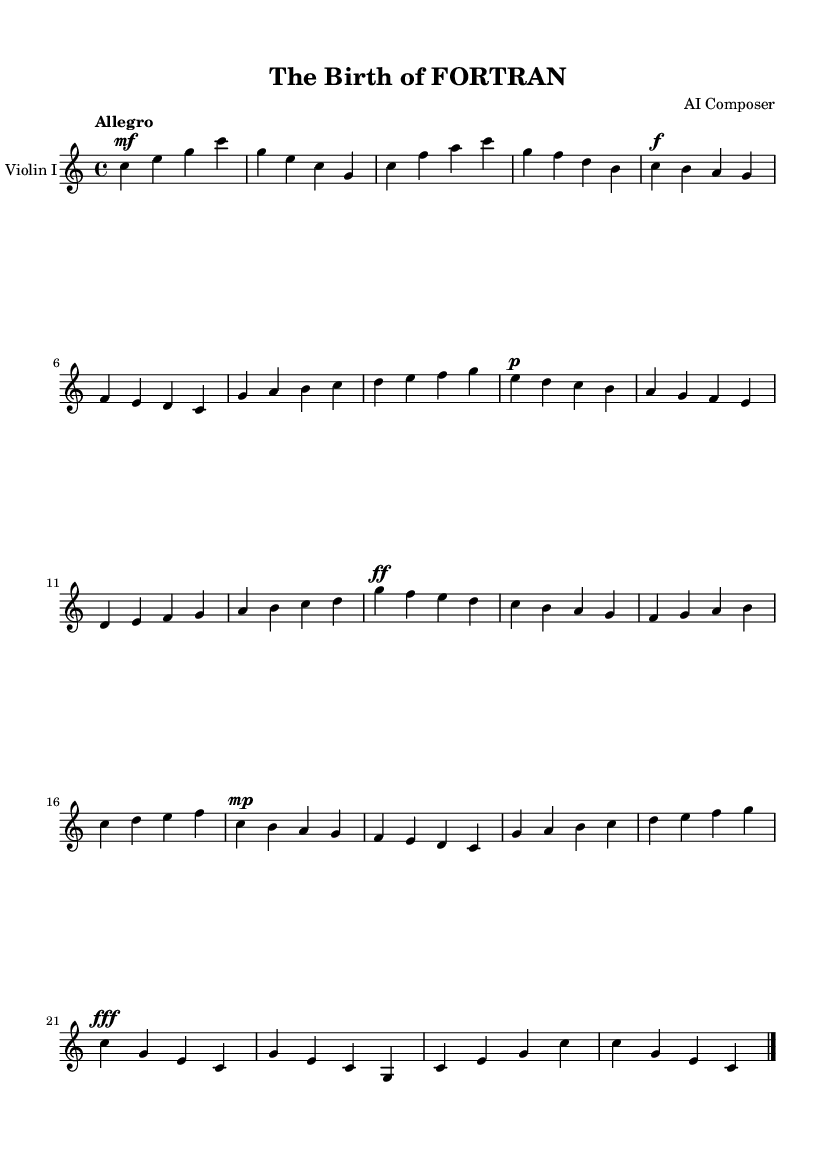What is the key signature of this music? The key signature is C major, which is identified by the absence of any sharps or flats in the key signature section of the sheet music.
Answer: C major What is the time signature of this music? The time signature is located at the beginning of the staff, indicated by the fraction 4/4, which means there are four beats in a measure and a quarter note receives one beat.
Answer: 4/4 What is the tempo marking for this music? The tempo marking is indicated above the staff with the word "Allegro," which suggests a fast and lively pace for the piece.
Answer: Allegro How many measures are there in total? By counting the number of distinct segments separated by vertical lines in the music notation, there are 16 measures present in the score.
Answer: 16 What dynamic marking is found at the beginning of the piece? The dynamic marking at the beginning of the piece is "mf," which stands for mezzo-forte, indicating a moderately loud volume for the violin part.
Answer: mf What is the last note played in this piece? The last note is indicated before the final bar line, which is a "c" in the bass octave, as can be confirmed by visual inspection of the score.
Answer: c 